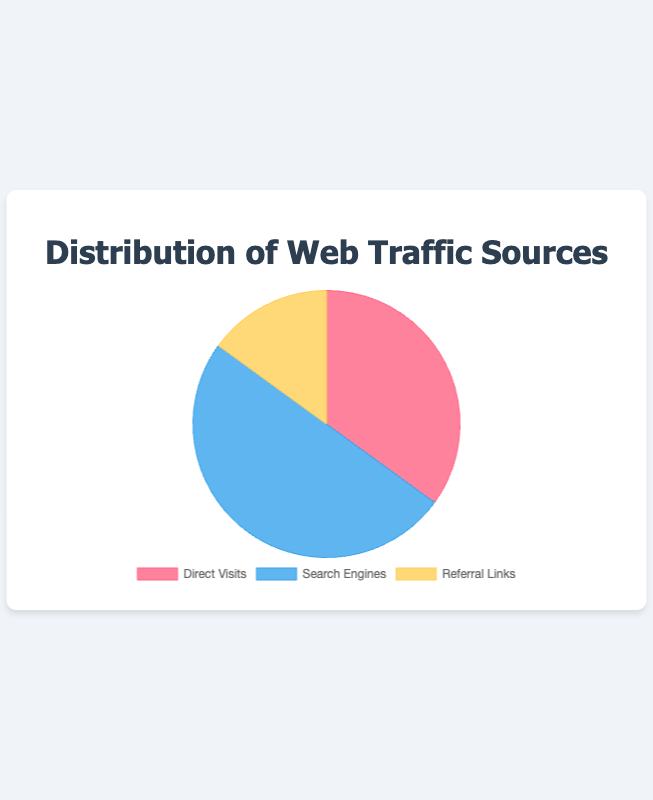what percentage of web traffic comes from search engines? The data shows that search engines contribute 50% of web traffic.
Answer: 50% which source has the lowest percentage of web traffic? The data shows that referral links have the lowest percentage at 15%.
Answer: Referral Links how much more traffic do search engines generate compared to direct visits? The traffic from search engines is 50% and from direct visits is 35%. The difference is 50% - 35% = 15%.
Answer: 15% what is the combined percentage of traffic from direct visits and referral links? The traffic from direct visits is 35% and from referral links is 15%. The combined percentage is 35% + 15% = 50%.
Answer: 50% are search engines the largest source of web traffic? Yes, because search engines contribute 50% of the total web traffic, which is the highest among all sources.
Answer: Yes what percentage of web traffic comes from sources other than referral links? Traffic from sources other than referral links is the sum of direct visits and search engines: 35% + 50% = 85%.
Answer: 85% which traffic source is represented by the blue segment in the pie chart? The blue segment, according to the color scheme typically used, corresponds to search engines.
Answer: Search Engines what is the difference in web traffic between the highest and lowest sources? The highest source is search engines at 50%, and the lowest is referral links at 15%. The difference is 50% - 15% = 35%.
Answer: 35% if we wanted to increase referral link traffic to match direct visits, what would be the required increase in percentage? Referral links are at 15%, and direct visits are at 35%. The increase required is 35% - 15% = 20%.
Answer: 20% which traffic source is closest to one-third of the total web traffic? One-third of the total web traffic is approximately 33.33%. Direct visits are closest at 35%.
Answer: Direct Visits 